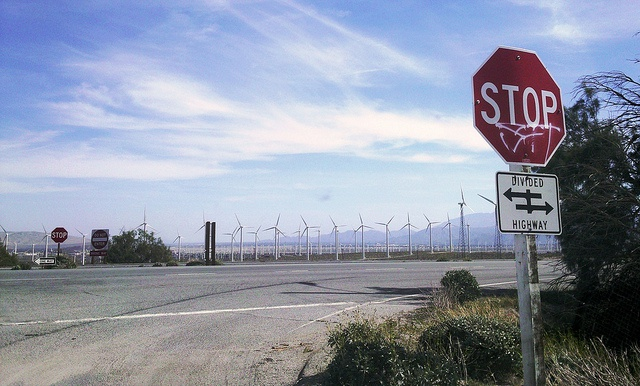Describe the objects in this image and their specific colors. I can see stop sign in blue, maroon, darkgray, and purple tones and stop sign in blue, black, gray, and darkgray tones in this image. 